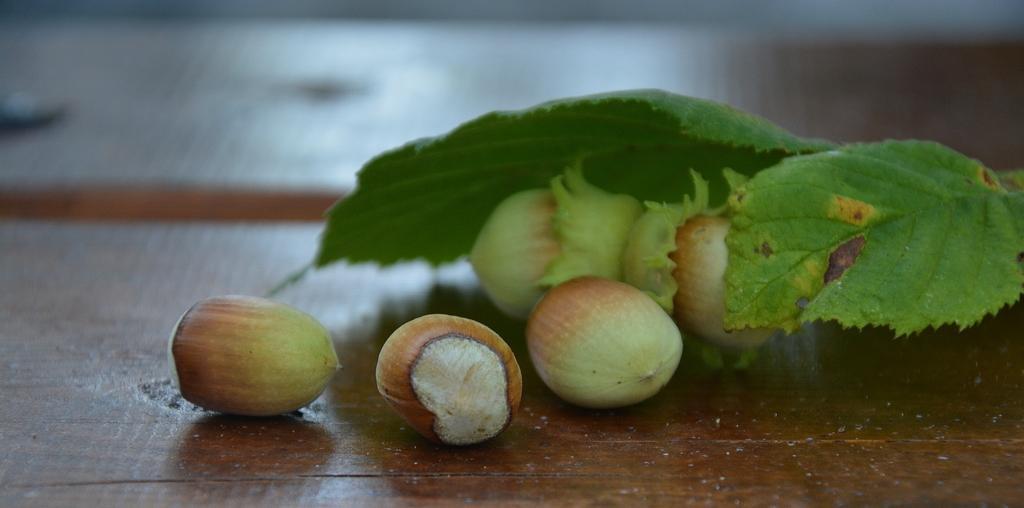Describe this image in one or two sentences. In this image, we can see hazelnuts on the wooden surface. Here we can see green leaves. Background we can see the blur view. 